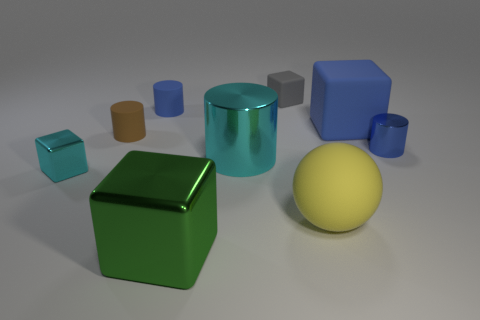Could you guess the purpose of this image? This image might be used for various purposes, such as a demonstration of 3D rendering techniques, material sampling, or a study of geometric shapes and light interaction. 